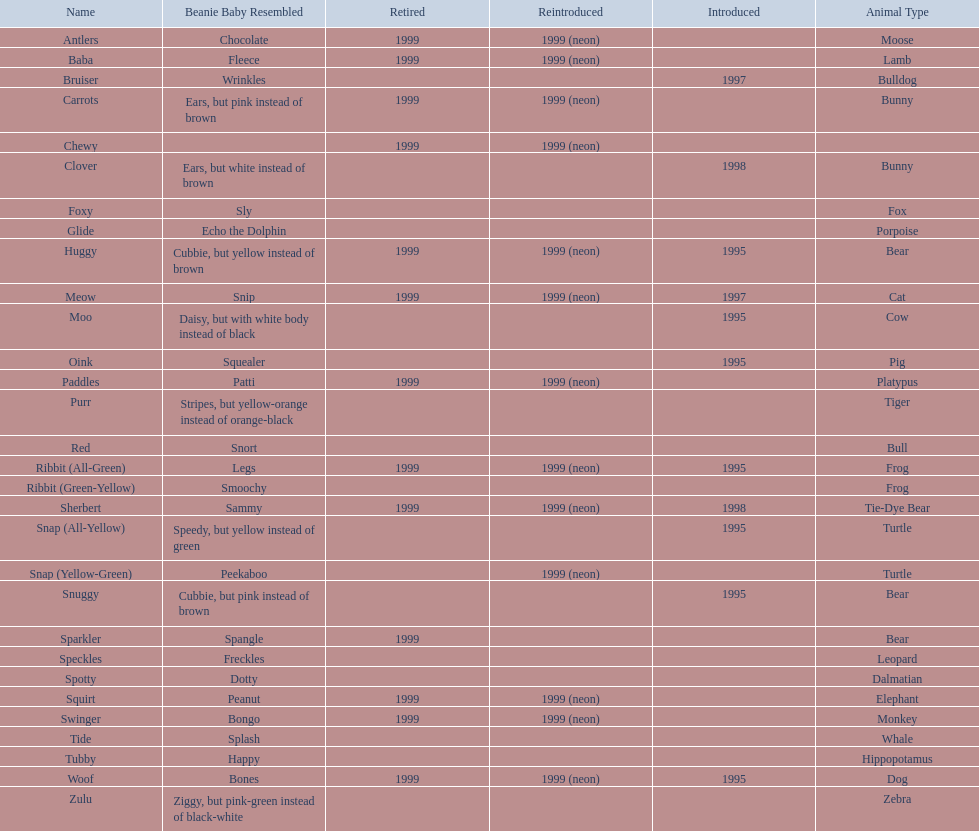What animals are pillow pals? Moose, Lamb, Bulldog, Bunny, Bunny, Fox, Porpoise, Bear, Cat, Cow, Pig, Platypus, Tiger, Bull, Frog, Frog, Tie-Dye Bear, Turtle, Turtle, Bear, Bear, Leopard, Dalmatian, Elephant, Monkey, Whale, Hippopotamus, Dog, Zebra. What is the name of the dalmatian? Spotty. 